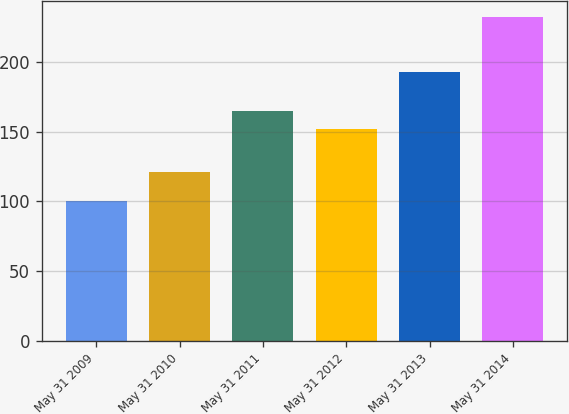Convert chart to OTSL. <chart><loc_0><loc_0><loc_500><loc_500><bar_chart><fcel>May 31 2009<fcel>May 31 2010<fcel>May 31 2011<fcel>May 31 2012<fcel>May 31 2013<fcel>May 31 2014<nl><fcel>100<fcel>120.99<fcel>165.02<fcel>151.76<fcel>193.15<fcel>232.64<nl></chart> 